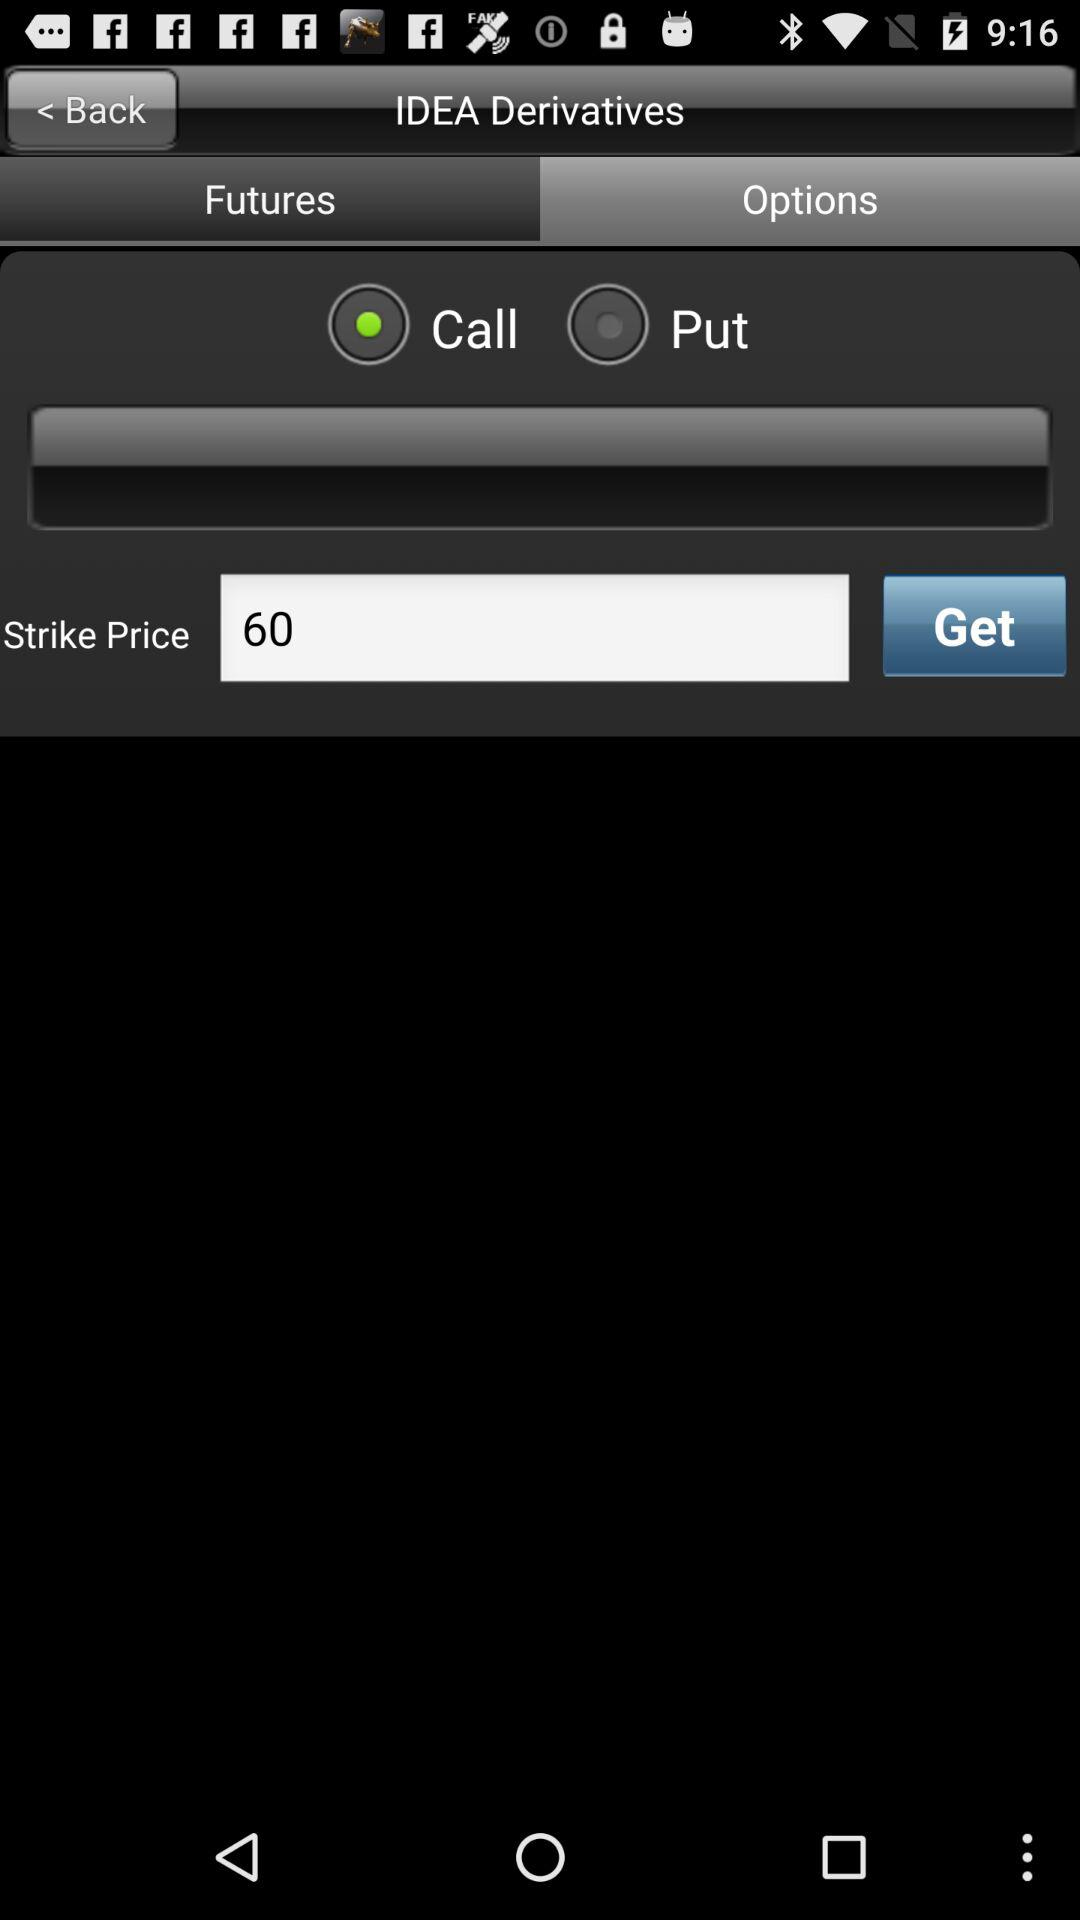What is the given strike price? The given strike price is 60. 